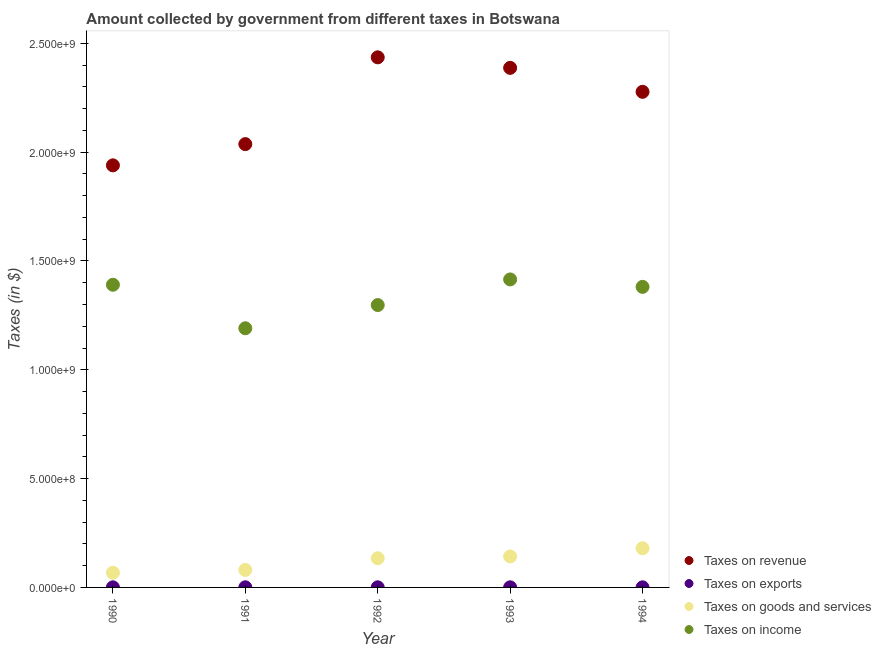How many different coloured dotlines are there?
Provide a short and direct response. 4. Is the number of dotlines equal to the number of legend labels?
Offer a very short reply. Yes. What is the amount collected as tax on income in 1992?
Give a very brief answer. 1.30e+09. Across all years, what is the maximum amount collected as tax on income?
Ensure brevity in your answer.  1.42e+09. Across all years, what is the minimum amount collected as tax on goods?
Make the answer very short. 6.75e+07. In which year was the amount collected as tax on goods maximum?
Keep it short and to the point. 1994. In which year was the amount collected as tax on income minimum?
Your answer should be very brief. 1991. What is the total amount collected as tax on income in the graph?
Offer a terse response. 6.68e+09. What is the difference between the amount collected as tax on exports in 1992 and that in 1994?
Provide a succinct answer. 1.00e+05. What is the difference between the amount collected as tax on revenue in 1994 and the amount collected as tax on goods in 1991?
Ensure brevity in your answer.  2.20e+09. What is the average amount collected as tax on income per year?
Offer a very short reply. 1.34e+09. In the year 1990, what is the difference between the amount collected as tax on goods and amount collected as tax on exports?
Ensure brevity in your answer.  6.71e+07. In how many years, is the amount collected as tax on revenue greater than 2300000000 $?
Your answer should be very brief. 2. What is the difference between the highest and the second highest amount collected as tax on income?
Give a very brief answer. 2.45e+07. What is the difference between the highest and the lowest amount collected as tax on exports?
Offer a very short reply. 2.00e+05. In how many years, is the amount collected as tax on income greater than the average amount collected as tax on income taken over all years?
Provide a short and direct response. 3. Is the sum of the amount collected as tax on goods in 1991 and 1993 greater than the maximum amount collected as tax on revenue across all years?
Make the answer very short. No. Does the amount collected as tax on goods monotonically increase over the years?
Your answer should be compact. Yes. Is the amount collected as tax on exports strictly less than the amount collected as tax on goods over the years?
Provide a short and direct response. Yes. What is the difference between two consecutive major ticks on the Y-axis?
Offer a very short reply. 5.00e+08. Are the values on the major ticks of Y-axis written in scientific E-notation?
Give a very brief answer. Yes. Does the graph contain grids?
Provide a succinct answer. No. Where does the legend appear in the graph?
Offer a very short reply. Bottom right. What is the title of the graph?
Give a very brief answer. Amount collected by government from different taxes in Botswana. Does "Social Protection" appear as one of the legend labels in the graph?
Your answer should be very brief. No. What is the label or title of the X-axis?
Your answer should be very brief. Year. What is the label or title of the Y-axis?
Your response must be concise. Taxes (in $). What is the Taxes (in $) in Taxes on revenue in 1990?
Keep it short and to the point. 1.94e+09. What is the Taxes (in $) in Taxes on goods and services in 1990?
Provide a short and direct response. 6.75e+07. What is the Taxes (in $) of Taxes on income in 1990?
Ensure brevity in your answer.  1.39e+09. What is the Taxes (in $) of Taxes on revenue in 1991?
Make the answer very short. 2.04e+09. What is the Taxes (in $) in Taxes on exports in 1991?
Keep it short and to the point. 6.00e+05. What is the Taxes (in $) in Taxes on goods and services in 1991?
Give a very brief answer. 8.04e+07. What is the Taxes (in $) of Taxes on income in 1991?
Give a very brief answer. 1.19e+09. What is the Taxes (in $) of Taxes on revenue in 1992?
Your answer should be compact. 2.44e+09. What is the Taxes (in $) in Taxes on goods and services in 1992?
Provide a succinct answer. 1.34e+08. What is the Taxes (in $) of Taxes on income in 1992?
Make the answer very short. 1.30e+09. What is the Taxes (in $) of Taxes on revenue in 1993?
Your response must be concise. 2.39e+09. What is the Taxes (in $) in Taxes on exports in 1993?
Ensure brevity in your answer.  5.00e+05. What is the Taxes (in $) in Taxes on goods and services in 1993?
Give a very brief answer. 1.42e+08. What is the Taxes (in $) in Taxes on income in 1993?
Give a very brief answer. 1.42e+09. What is the Taxes (in $) of Taxes on revenue in 1994?
Your response must be concise. 2.28e+09. What is the Taxes (in $) in Taxes on exports in 1994?
Your answer should be compact. 4.00e+05. What is the Taxes (in $) in Taxes on goods and services in 1994?
Give a very brief answer. 1.80e+08. What is the Taxes (in $) in Taxes on income in 1994?
Offer a very short reply. 1.38e+09. Across all years, what is the maximum Taxes (in $) in Taxes on revenue?
Offer a terse response. 2.44e+09. Across all years, what is the maximum Taxes (in $) of Taxes on goods and services?
Your answer should be compact. 1.80e+08. Across all years, what is the maximum Taxes (in $) of Taxes on income?
Provide a succinct answer. 1.42e+09. Across all years, what is the minimum Taxes (in $) of Taxes on revenue?
Keep it short and to the point. 1.94e+09. Across all years, what is the minimum Taxes (in $) of Taxes on goods and services?
Keep it short and to the point. 6.75e+07. Across all years, what is the minimum Taxes (in $) in Taxes on income?
Provide a succinct answer. 1.19e+09. What is the total Taxes (in $) of Taxes on revenue in the graph?
Provide a short and direct response. 1.11e+1. What is the total Taxes (in $) of Taxes on exports in the graph?
Provide a succinct answer. 2.44e+06. What is the total Taxes (in $) in Taxes on goods and services in the graph?
Your answer should be very brief. 6.04e+08. What is the total Taxes (in $) of Taxes on income in the graph?
Your response must be concise. 6.68e+09. What is the difference between the Taxes (in $) in Taxes on revenue in 1990 and that in 1991?
Offer a terse response. -9.76e+07. What is the difference between the Taxes (in $) in Taxes on goods and services in 1990 and that in 1991?
Offer a terse response. -1.29e+07. What is the difference between the Taxes (in $) of Taxes on income in 1990 and that in 1991?
Provide a succinct answer. 2.00e+08. What is the difference between the Taxes (in $) of Taxes on revenue in 1990 and that in 1992?
Offer a terse response. -4.96e+08. What is the difference between the Taxes (in $) in Taxes on exports in 1990 and that in 1992?
Provide a short and direct response. -6.00e+04. What is the difference between the Taxes (in $) in Taxes on goods and services in 1990 and that in 1992?
Keep it short and to the point. -6.66e+07. What is the difference between the Taxes (in $) of Taxes on income in 1990 and that in 1992?
Ensure brevity in your answer.  9.33e+07. What is the difference between the Taxes (in $) in Taxes on revenue in 1990 and that in 1993?
Your response must be concise. -4.48e+08. What is the difference between the Taxes (in $) in Taxes on exports in 1990 and that in 1993?
Provide a short and direct response. -6.00e+04. What is the difference between the Taxes (in $) in Taxes on goods and services in 1990 and that in 1993?
Your response must be concise. -7.49e+07. What is the difference between the Taxes (in $) of Taxes on income in 1990 and that in 1993?
Provide a short and direct response. -2.45e+07. What is the difference between the Taxes (in $) of Taxes on revenue in 1990 and that in 1994?
Your response must be concise. -3.38e+08. What is the difference between the Taxes (in $) in Taxes on exports in 1990 and that in 1994?
Your answer should be compact. 4.00e+04. What is the difference between the Taxes (in $) in Taxes on goods and services in 1990 and that in 1994?
Keep it short and to the point. -1.12e+08. What is the difference between the Taxes (in $) of Taxes on income in 1990 and that in 1994?
Offer a terse response. 9.70e+06. What is the difference between the Taxes (in $) of Taxes on revenue in 1991 and that in 1992?
Keep it short and to the point. -3.99e+08. What is the difference between the Taxes (in $) in Taxes on exports in 1991 and that in 1992?
Provide a succinct answer. 1.00e+05. What is the difference between the Taxes (in $) in Taxes on goods and services in 1991 and that in 1992?
Offer a very short reply. -5.37e+07. What is the difference between the Taxes (in $) of Taxes on income in 1991 and that in 1992?
Offer a terse response. -1.07e+08. What is the difference between the Taxes (in $) of Taxes on revenue in 1991 and that in 1993?
Your answer should be compact. -3.50e+08. What is the difference between the Taxes (in $) in Taxes on goods and services in 1991 and that in 1993?
Your response must be concise. -6.20e+07. What is the difference between the Taxes (in $) in Taxes on income in 1991 and that in 1993?
Provide a succinct answer. -2.24e+08. What is the difference between the Taxes (in $) in Taxes on revenue in 1991 and that in 1994?
Make the answer very short. -2.40e+08. What is the difference between the Taxes (in $) of Taxes on exports in 1991 and that in 1994?
Your answer should be very brief. 2.00e+05. What is the difference between the Taxes (in $) of Taxes on goods and services in 1991 and that in 1994?
Keep it short and to the point. -9.96e+07. What is the difference between the Taxes (in $) in Taxes on income in 1991 and that in 1994?
Offer a terse response. -1.90e+08. What is the difference between the Taxes (in $) in Taxes on revenue in 1992 and that in 1993?
Ensure brevity in your answer.  4.84e+07. What is the difference between the Taxes (in $) of Taxes on goods and services in 1992 and that in 1993?
Your answer should be compact. -8.30e+06. What is the difference between the Taxes (in $) in Taxes on income in 1992 and that in 1993?
Make the answer very short. -1.18e+08. What is the difference between the Taxes (in $) in Taxes on revenue in 1992 and that in 1994?
Give a very brief answer. 1.58e+08. What is the difference between the Taxes (in $) of Taxes on exports in 1992 and that in 1994?
Your answer should be compact. 1.00e+05. What is the difference between the Taxes (in $) of Taxes on goods and services in 1992 and that in 1994?
Your answer should be compact. -4.59e+07. What is the difference between the Taxes (in $) in Taxes on income in 1992 and that in 1994?
Your answer should be very brief. -8.36e+07. What is the difference between the Taxes (in $) of Taxes on revenue in 1993 and that in 1994?
Provide a short and direct response. 1.10e+08. What is the difference between the Taxes (in $) of Taxes on exports in 1993 and that in 1994?
Provide a succinct answer. 1.00e+05. What is the difference between the Taxes (in $) in Taxes on goods and services in 1993 and that in 1994?
Offer a terse response. -3.76e+07. What is the difference between the Taxes (in $) in Taxes on income in 1993 and that in 1994?
Make the answer very short. 3.42e+07. What is the difference between the Taxes (in $) of Taxes on revenue in 1990 and the Taxes (in $) of Taxes on exports in 1991?
Make the answer very short. 1.94e+09. What is the difference between the Taxes (in $) of Taxes on revenue in 1990 and the Taxes (in $) of Taxes on goods and services in 1991?
Keep it short and to the point. 1.86e+09. What is the difference between the Taxes (in $) of Taxes on revenue in 1990 and the Taxes (in $) of Taxes on income in 1991?
Your answer should be very brief. 7.49e+08. What is the difference between the Taxes (in $) in Taxes on exports in 1990 and the Taxes (in $) in Taxes on goods and services in 1991?
Your answer should be compact. -8.00e+07. What is the difference between the Taxes (in $) in Taxes on exports in 1990 and the Taxes (in $) in Taxes on income in 1991?
Make the answer very short. -1.19e+09. What is the difference between the Taxes (in $) of Taxes on goods and services in 1990 and the Taxes (in $) of Taxes on income in 1991?
Your answer should be very brief. -1.12e+09. What is the difference between the Taxes (in $) in Taxes on revenue in 1990 and the Taxes (in $) in Taxes on exports in 1992?
Ensure brevity in your answer.  1.94e+09. What is the difference between the Taxes (in $) of Taxes on revenue in 1990 and the Taxes (in $) of Taxes on goods and services in 1992?
Make the answer very short. 1.81e+09. What is the difference between the Taxes (in $) of Taxes on revenue in 1990 and the Taxes (in $) of Taxes on income in 1992?
Provide a short and direct response. 6.42e+08. What is the difference between the Taxes (in $) in Taxes on exports in 1990 and the Taxes (in $) in Taxes on goods and services in 1992?
Give a very brief answer. -1.34e+08. What is the difference between the Taxes (in $) in Taxes on exports in 1990 and the Taxes (in $) in Taxes on income in 1992?
Keep it short and to the point. -1.30e+09. What is the difference between the Taxes (in $) in Taxes on goods and services in 1990 and the Taxes (in $) in Taxes on income in 1992?
Offer a very short reply. -1.23e+09. What is the difference between the Taxes (in $) in Taxes on revenue in 1990 and the Taxes (in $) in Taxes on exports in 1993?
Keep it short and to the point. 1.94e+09. What is the difference between the Taxes (in $) in Taxes on revenue in 1990 and the Taxes (in $) in Taxes on goods and services in 1993?
Provide a short and direct response. 1.80e+09. What is the difference between the Taxes (in $) of Taxes on revenue in 1990 and the Taxes (in $) of Taxes on income in 1993?
Your response must be concise. 5.24e+08. What is the difference between the Taxes (in $) of Taxes on exports in 1990 and the Taxes (in $) of Taxes on goods and services in 1993?
Ensure brevity in your answer.  -1.42e+08. What is the difference between the Taxes (in $) of Taxes on exports in 1990 and the Taxes (in $) of Taxes on income in 1993?
Your answer should be compact. -1.41e+09. What is the difference between the Taxes (in $) in Taxes on goods and services in 1990 and the Taxes (in $) in Taxes on income in 1993?
Offer a very short reply. -1.35e+09. What is the difference between the Taxes (in $) in Taxes on revenue in 1990 and the Taxes (in $) in Taxes on exports in 1994?
Provide a short and direct response. 1.94e+09. What is the difference between the Taxes (in $) in Taxes on revenue in 1990 and the Taxes (in $) in Taxes on goods and services in 1994?
Your response must be concise. 1.76e+09. What is the difference between the Taxes (in $) in Taxes on revenue in 1990 and the Taxes (in $) in Taxes on income in 1994?
Give a very brief answer. 5.58e+08. What is the difference between the Taxes (in $) of Taxes on exports in 1990 and the Taxes (in $) of Taxes on goods and services in 1994?
Your answer should be compact. -1.80e+08. What is the difference between the Taxes (in $) in Taxes on exports in 1990 and the Taxes (in $) in Taxes on income in 1994?
Ensure brevity in your answer.  -1.38e+09. What is the difference between the Taxes (in $) of Taxes on goods and services in 1990 and the Taxes (in $) of Taxes on income in 1994?
Offer a very short reply. -1.31e+09. What is the difference between the Taxes (in $) of Taxes on revenue in 1991 and the Taxes (in $) of Taxes on exports in 1992?
Your response must be concise. 2.04e+09. What is the difference between the Taxes (in $) in Taxes on revenue in 1991 and the Taxes (in $) in Taxes on goods and services in 1992?
Offer a terse response. 1.90e+09. What is the difference between the Taxes (in $) in Taxes on revenue in 1991 and the Taxes (in $) in Taxes on income in 1992?
Ensure brevity in your answer.  7.40e+08. What is the difference between the Taxes (in $) in Taxes on exports in 1991 and the Taxes (in $) in Taxes on goods and services in 1992?
Make the answer very short. -1.34e+08. What is the difference between the Taxes (in $) of Taxes on exports in 1991 and the Taxes (in $) of Taxes on income in 1992?
Provide a succinct answer. -1.30e+09. What is the difference between the Taxes (in $) of Taxes on goods and services in 1991 and the Taxes (in $) of Taxes on income in 1992?
Ensure brevity in your answer.  -1.22e+09. What is the difference between the Taxes (in $) in Taxes on revenue in 1991 and the Taxes (in $) in Taxes on exports in 1993?
Make the answer very short. 2.04e+09. What is the difference between the Taxes (in $) of Taxes on revenue in 1991 and the Taxes (in $) of Taxes on goods and services in 1993?
Give a very brief answer. 1.89e+09. What is the difference between the Taxes (in $) in Taxes on revenue in 1991 and the Taxes (in $) in Taxes on income in 1993?
Your answer should be compact. 6.22e+08. What is the difference between the Taxes (in $) in Taxes on exports in 1991 and the Taxes (in $) in Taxes on goods and services in 1993?
Your response must be concise. -1.42e+08. What is the difference between the Taxes (in $) in Taxes on exports in 1991 and the Taxes (in $) in Taxes on income in 1993?
Give a very brief answer. -1.41e+09. What is the difference between the Taxes (in $) of Taxes on goods and services in 1991 and the Taxes (in $) of Taxes on income in 1993?
Make the answer very short. -1.33e+09. What is the difference between the Taxes (in $) of Taxes on revenue in 1991 and the Taxes (in $) of Taxes on exports in 1994?
Your answer should be compact. 2.04e+09. What is the difference between the Taxes (in $) in Taxes on revenue in 1991 and the Taxes (in $) in Taxes on goods and services in 1994?
Your answer should be compact. 1.86e+09. What is the difference between the Taxes (in $) of Taxes on revenue in 1991 and the Taxes (in $) of Taxes on income in 1994?
Keep it short and to the point. 6.56e+08. What is the difference between the Taxes (in $) in Taxes on exports in 1991 and the Taxes (in $) in Taxes on goods and services in 1994?
Ensure brevity in your answer.  -1.79e+08. What is the difference between the Taxes (in $) in Taxes on exports in 1991 and the Taxes (in $) in Taxes on income in 1994?
Provide a short and direct response. -1.38e+09. What is the difference between the Taxes (in $) in Taxes on goods and services in 1991 and the Taxes (in $) in Taxes on income in 1994?
Your response must be concise. -1.30e+09. What is the difference between the Taxes (in $) in Taxes on revenue in 1992 and the Taxes (in $) in Taxes on exports in 1993?
Offer a very short reply. 2.44e+09. What is the difference between the Taxes (in $) in Taxes on revenue in 1992 and the Taxes (in $) in Taxes on goods and services in 1993?
Ensure brevity in your answer.  2.29e+09. What is the difference between the Taxes (in $) of Taxes on revenue in 1992 and the Taxes (in $) of Taxes on income in 1993?
Your answer should be very brief. 1.02e+09. What is the difference between the Taxes (in $) of Taxes on exports in 1992 and the Taxes (in $) of Taxes on goods and services in 1993?
Offer a very short reply. -1.42e+08. What is the difference between the Taxes (in $) of Taxes on exports in 1992 and the Taxes (in $) of Taxes on income in 1993?
Provide a succinct answer. -1.41e+09. What is the difference between the Taxes (in $) in Taxes on goods and services in 1992 and the Taxes (in $) in Taxes on income in 1993?
Make the answer very short. -1.28e+09. What is the difference between the Taxes (in $) in Taxes on revenue in 1992 and the Taxes (in $) in Taxes on exports in 1994?
Give a very brief answer. 2.44e+09. What is the difference between the Taxes (in $) of Taxes on revenue in 1992 and the Taxes (in $) of Taxes on goods and services in 1994?
Keep it short and to the point. 2.26e+09. What is the difference between the Taxes (in $) of Taxes on revenue in 1992 and the Taxes (in $) of Taxes on income in 1994?
Your answer should be very brief. 1.05e+09. What is the difference between the Taxes (in $) in Taxes on exports in 1992 and the Taxes (in $) in Taxes on goods and services in 1994?
Ensure brevity in your answer.  -1.80e+08. What is the difference between the Taxes (in $) of Taxes on exports in 1992 and the Taxes (in $) of Taxes on income in 1994?
Keep it short and to the point. -1.38e+09. What is the difference between the Taxes (in $) of Taxes on goods and services in 1992 and the Taxes (in $) of Taxes on income in 1994?
Offer a terse response. -1.25e+09. What is the difference between the Taxes (in $) of Taxes on revenue in 1993 and the Taxes (in $) of Taxes on exports in 1994?
Your answer should be very brief. 2.39e+09. What is the difference between the Taxes (in $) of Taxes on revenue in 1993 and the Taxes (in $) of Taxes on goods and services in 1994?
Provide a succinct answer. 2.21e+09. What is the difference between the Taxes (in $) of Taxes on revenue in 1993 and the Taxes (in $) of Taxes on income in 1994?
Make the answer very short. 1.01e+09. What is the difference between the Taxes (in $) in Taxes on exports in 1993 and the Taxes (in $) in Taxes on goods and services in 1994?
Offer a terse response. -1.80e+08. What is the difference between the Taxes (in $) in Taxes on exports in 1993 and the Taxes (in $) in Taxes on income in 1994?
Offer a terse response. -1.38e+09. What is the difference between the Taxes (in $) of Taxes on goods and services in 1993 and the Taxes (in $) of Taxes on income in 1994?
Provide a short and direct response. -1.24e+09. What is the average Taxes (in $) of Taxes on revenue per year?
Offer a very short reply. 2.22e+09. What is the average Taxes (in $) in Taxes on exports per year?
Your answer should be compact. 4.88e+05. What is the average Taxes (in $) of Taxes on goods and services per year?
Keep it short and to the point. 1.21e+08. What is the average Taxes (in $) in Taxes on income per year?
Keep it short and to the point. 1.34e+09. In the year 1990, what is the difference between the Taxes (in $) of Taxes on revenue and Taxes (in $) of Taxes on exports?
Your answer should be very brief. 1.94e+09. In the year 1990, what is the difference between the Taxes (in $) of Taxes on revenue and Taxes (in $) of Taxes on goods and services?
Keep it short and to the point. 1.87e+09. In the year 1990, what is the difference between the Taxes (in $) of Taxes on revenue and Taxes (in $) of Taxes on income?
Provide a succinct answer. 5.49e+08. In the year 1990, what is the difference between the Taxes (in $) in Taxes on exports and Taxes (in $) in Taxes on goods and services?
Provide a succinct answer. -6.71e+07. In the year 1990, what is the difference between the Taxes (in $) in Taxes on exports and Taxes (in $) in Taxes on income?
Make the answer very short. -1.39e+09. In the year 1990, what is the difference between the Taxes (in $) of Taxes on goods and services and Taxes (in $) of Taxes on income?
Give a very brief answer. -1.32e+09. In the year 1991, what is the difference between the Taxes (in $) of Taxes on revenue and Taxes (in $) of Taxes on exports?
Your answer should be very brief. 2.04e+09. In the year 1991, what is the difference between the Taxes (in $) of Taxes on revenue and Taxes (in $) of Taxes on goods and services?
Keep it short and to the point. 1.96e+09. In the year 1991, what is the difference between the Taxes (in $) in Taxes on revenue and Taxes (in $) in Taxes on income?
Ensure brevity in your answer.  8.46e+08. In the year 1991, what is the difference between the Taxes (in $) in Taxes on exports and Taxes (in $) in Taxes on goods and services?
Your answer should be very brief. -7.98e+07. In the year 1991, what is the difference between the Taxes (in $) of Taxes on exports and Taxes (in $) of Taxes on income?
Offer a very short reply. -1.19e+09. In the year 1991, what is the difference between the Taxes (in $) in Taxes on goods and services and Taxes (in $) in Taxes on income?
Ensure brevity in your answer.  -1.11e+09. In the year 1992, what is the difference between the Taxes (in $) of Taxes on revenue and Taxes (in $) of Taxes on exports?
Make the answer very short. 2.44e+09. In the year 1992, what is the difference between the Taxes (in $) in Taxes on revenue and Taxes (in $) in Taxes on goods and services?
Offer a terse response. 2.30e+09. In the year 1992, what is the difference between the Taxes (in $) of Taxes on revenue and Taxes (in $) of Taxes on income?
Your answer should be compact. 1.14e+09. In the year 1992, what is the difference between the Taxes (in $) in Taxes on exports and Taxes (in $) in Taxes on goods and services?
Your response must be concise. -1.34e+08. In the year 1992, what is the difference between the Taxes (in $) of Taxes on exports and Taxes (in $) of Taxes on income?
Offer a very short reply. -1.30e+09. In the year 1992, what is the difference between the Taxes (in $) in Taxes on goods and services and Taxes (in $) in Taxes on income?
Offer a terse response. -1.16e+09. In the year 1993, what is the difference between the Taxes (in $) in Taxes on revenue and Taxes (in $) in Taxes on exports?
Your answer should be very brief. 2.39e+09. In the year 1993, what is the difference between the Taxes (in $) of Taxes on revenue and Taxes (in $) of Taxes on goods and services?
Keep it short and to the point. 2.25e+09. In the year 1993, what is the difference between the Taxes (in $) in Taxes on revenue and Taxes (in $) in Taxes on income?
Make the answer very short. 9.72e+08. In the year 1993, what is the difference between the Taxes (in $) of Taxes on exports and Taxes (in $) of Taxes on goods and services?
Provide a succinct answer. -1.42e+08. In the year 1993, what is the difference between the Taxes (in $) of Taxes on exports and Taxes (in $) of Taxes on income?
Provide a succinct answer. -1.41e+09. In the year 1993, what is the difference between the Taxes (in $) in Taxes on goods and services and Taxes (in $) in Taxes on income?
Give a very brief answer. -1.27e+09. In the year 1994, what is the difference between the Taxes (in $) of Taxes on revenue and Taxes (in $) of Taxes on exports?
Make the answer very short. 2.28e+09. In the year 1994, what is the difference between the Taxes (in $) of Taxes on revenue and Taxes (in $) of Taxes on goods and services?
Your answer should be compact. 2.10e+09. In the year 1994, what is the difference between the Taxes (in $) in Taxes on revenue and Taxes (in $) in Taxes on income?
Your answer should be compact. 8.96e+08. In the year 1994, what is the difference between the Taxes (in $) of Taxes on exports and Taxes (in $) of Taxes on goods and services?
Keep it short and to the point. -1.80e+08. In the year 1994, what is the difference between the Taxes (in $) in Taxes on exports and Taxes (in $) in Taxes on income?
Provide a succinct answer. -1.38e+09. In the year 1994, what is the difference between the Taxes (in $) in Taxes on goods and services and Taxes (in $) in Taxes on income?
Offer a very short reply. -1.20e+09. What is the ratio of the Taxes (in $) in Taxes on revenue in 1990 to that in 1991?
Ensure brevity in your answer.  0.95. What is the ratio of the Taxes (in $) of Taxes on exports in 1990 to that in 1991?
Keep it short and to the point. 0.73. What is the ratio of the Taxes (in $) in Taxes on goods and services in 1990 to that in 1991?
Provide a short and direct response. 0.84. What is the ratio of the Taxes (in $) in Taxes on income in 1990 to that in 1991?
Your answer should be very brief. 1.17. What is the ratio of the Taxes (in $) in Taxes on revenue in 1990 to that in 1992?
Offer a very short reply. 0.8. What is the ratio of the Taxes (in $) in Taxes on goods and services in 1990 to that in 1992?
Offer a very short reply. 0.5. What is the ratio of the Taxes (in $) in Taxes on income in 1990 to that in 1992?
Your response must be concise. 1.07. What is the ratio of the Taxes (in $) of Taxes on revenue in 1990 to that in 1993?
Make the answer very short. 0.81. What is the ratio of the Taxes (in $) in Taxes on exports in 1990 to that in 1993?
Your response must be concise. 0.88. What is the ratio of the Taxes (in $) of Taxes on goods and services in 1990 to that in 1993?
Keep it short and to the point. 0.47. What is the ratio of the Taxes (in $) of Taxes on income in 1990 to that in 1993?
Ensure brevity in your answer.  0.98. What is the ratio of the Taxes (in $) in Taxes on revenue in 1990 to that in 1994?
Your response must be concise. 0.85. What is the ratio of the Taxes (in $) of Taxes on exports in 1990 to that in 1994?
Provide a short and direct response. 1.1. What is the ratio of the Taxes (in $) of Taxes on goods and services in 1990 to that in 1994?
Make the answer very short. 0.38. What is the ratio of the Taxes (in $) of Taxes on income in 1990 to that in 1994?
Make the answer very short. 1.01. What is the ratio of the Taxes (in $) of Taxes on revenue in 1991 to that in 1992?
Offer a very short reply. 0.84. What is the ratio of the Taxes (in $) in Taxes on exports in 1991 to that in 1992?
Offer a very short reply. 1.2. What is the ratio of the Taxes (in $) of Taxes on goods and services in 1991 to that in 1992?
Your answer should be very brief. 0.6. What is the ratio of the Taxes (in $) of Taxes on income in 1991 to that in 1992?
Offer a terse response. 0.92. What is the ratio of the Taxes (in $) in Taxes on revenue in 1991 to that in 1993?
Ensure brevity in your answer.  0.85. What is the ratio of the Taxes (in $) of Taxes on goods and services in 1991 to that in 1993?
Provide a succinct answer. 0.56. What is the ratio of the Taxes (in $) in Taxes on income in 1991 to that in 1993?
Your answer should be very brief. 0.84. What is the ratio of the Taxes (in $) of Taxes on revenue in 1991 to that in 1994?
Your answer should be compact. 0.89. What is the ratio of the Taxes (in $) in Taxes on exports in 1991 to that in 1994?
Your answer should be compact. 1.5. What is the ratio of the Taxes (in $) of Taxes on goods and services in 1991 to that in 1994?
Offer a terse response. 0.45. What is the ratio of the Taxes (in $) of Taxes on income in 1991 to that in 1994?
Make the answer very short. 0.86. What is the ratio of the Taxes (in $) in Taxes on revenue in 1992 to that in 1993?
Ensure brevity in your answer.  1.02. What is the ratio of the Taxes (in $) of Taxes on exports in 1992 to that in 1993?
Offer a very short reply. 1. What is the ratio of the Taxes (in $) in Taxes on goods and services in 1992 to that in 1993?
Provide a succinct answer. 0.94. What is the ratio of the Taxes (in $) of Taxes on income in 1992 to that in 1993?
Ensure brevity in your answer.  0.92. What is the ratio of the Taxes (in $) of Taxes on revenue in 1992 to that in 1994?
Give a very brief answer. 1.07. What is the ratio of the Taxes (in $) in Taxes on exports in 1992 to that in 1994?
Keep it short and to the point. 1.25. What is the ratio of the Taxes (in $) of Taxes on goods and services in 1992 to that in 1994?
Keep it short and to the point. 0.74. What is the ratio of the Taxes (in $) of Taxes on income in 1992 to that in 1994?
Offer a very short reply. 0.94. What is the ratio of the Taxes (in $) in Taxes on revenue in 1993 to that in 1994?
Provide a succinct answer. 1.05. What is the ratio of the Taxes (in $) of Taxes on goods and services in 1993 to that in 1994?
Provide a succinct answer. 0.79. What is the ratio of the Taxes (in $) in Taxes on income in 1993 to that in 1994?
Offer a terse response. 1.02. What is the difference between the highest and the second highest Taxes (in $) of Taxes on revenue?
Offer a terse response. 4.84e+07. What is the difference between the highest and the second highest Taxes (in $) of Taxes on goods and services?
Offer a very short reply. 3.76e+07. What is the difference between the highest and the second highest Taxes (in $) in Taxes on income?
Offer a terse response. 2.45e+07. What is the difference between the highest and the lowest Taxes (in $) of Taxes on revenue?
Make the answer very short. 4.96e+08. What is the difference between the highest and the lowest Taxes (in $) in Taxes on goods and services?
Keep it short and to the point. 1.12e+08. What is the difference between the highest and the lowest Taxes (in $) of Taxes on income?
Provide a short and direct response. 2.24e+08. 